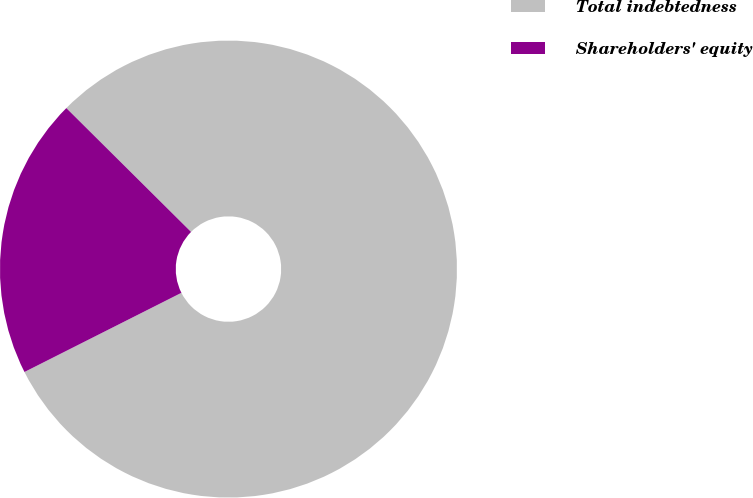Convert chart to OTSL. <chart><loc_0><loc_0><loc_500><loc_500><pie_chart><fcel>Total indebtedness<fcel>Shareholders' equity<nl><fcel>80.12%<fcel>19.88%<nl></chart> 